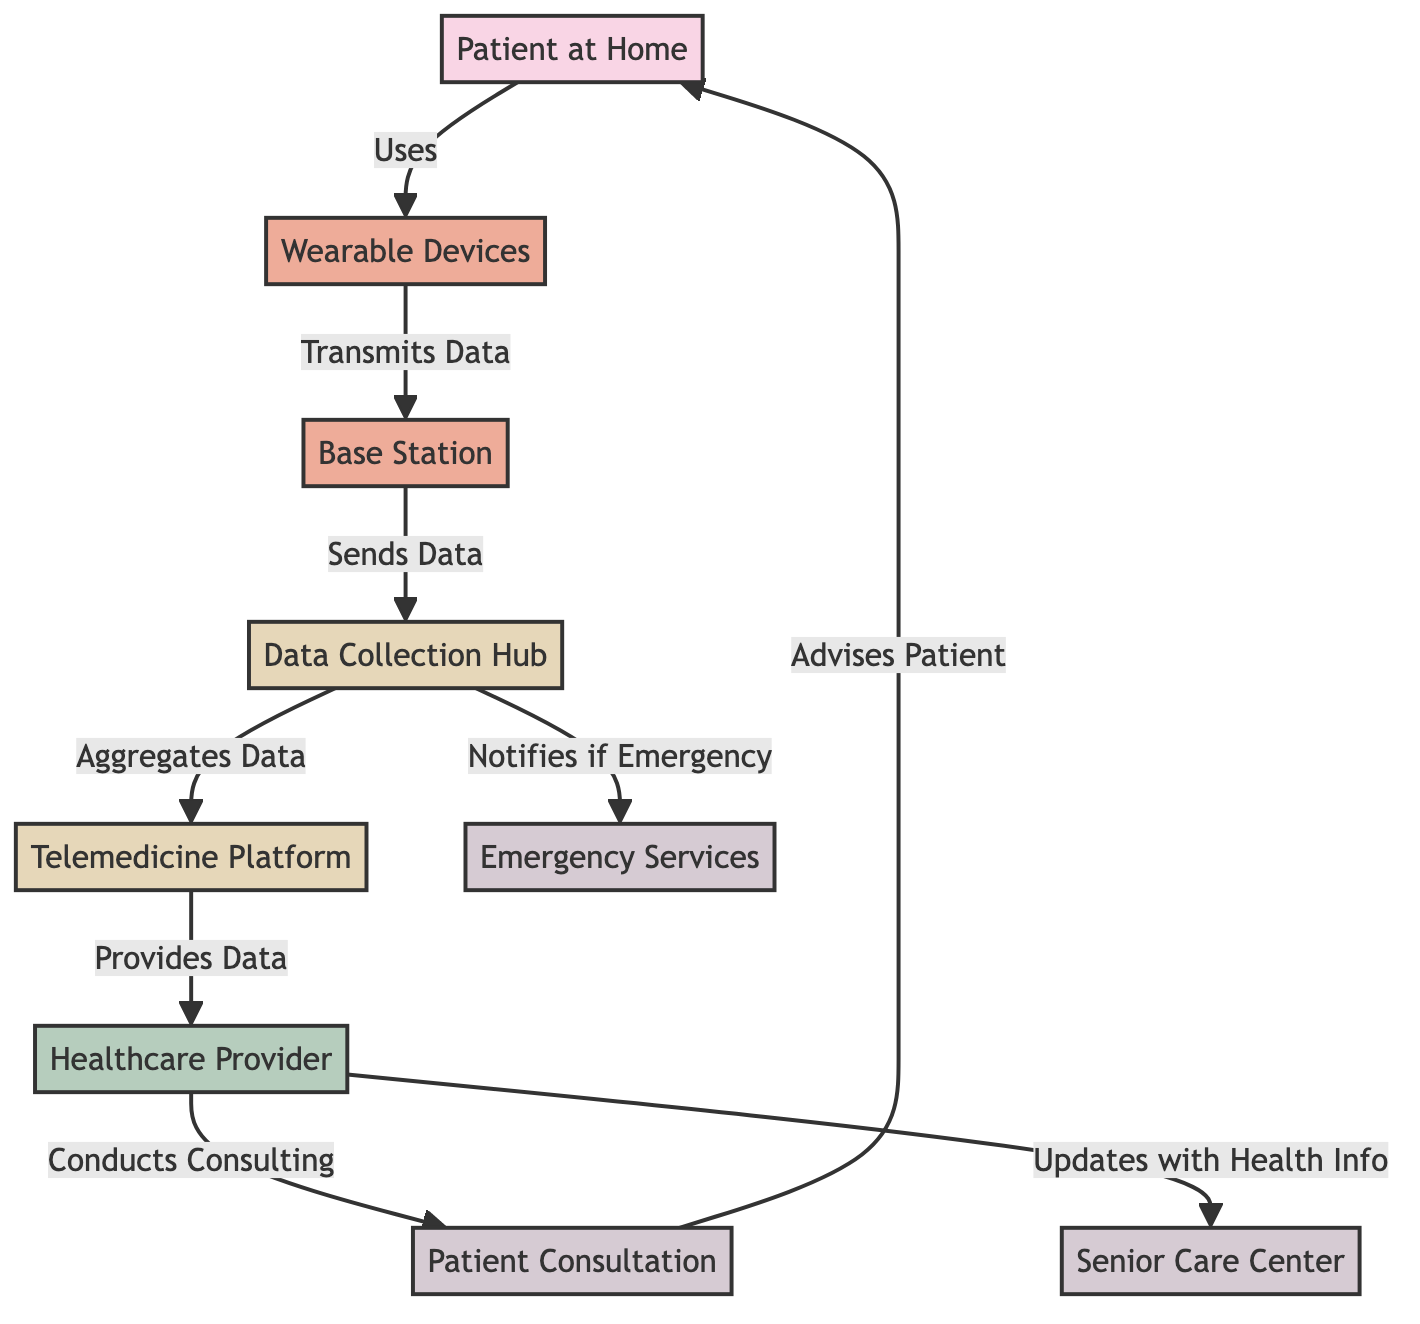What's the first step in the telemedicine process? The diagram indicates that the first step involves the "Patient at Home" using "Wearable Devices." This establishes the starting point of data collection in the telemedicine process.
Answer: Patient at Home How many wearable devices are illustrated in the diagram? The diagram includes one instance labeled "Wearable Devices," indicating there's a singular representation of this component.
Answer: One What does the "Base Station" do in this process? The "Base Station" transmits data from the "Wearable Devices" to the "Data Collection Hub," forming a crucial link in the data communication flow.
Answer: Transmits Data What is the outcome of the data collected from patients? The collected data is aggregated by the "Data Collection Hub," which indicates that this step organizes and prepares the information for the next stage of processing.
Answer: Aggregates Data What happens when an emergency is detected? If an emergency situation arises, the "Data Collection Hub" notifies "Emergency Services," showing the critical alert system in patient monitoring.
Answer: Notifies if Emergency How many services are listed in the diagram? The diagram shows four services: "Senior Care Center," "Patient Consultation," and "Emergency Services." Therefore, counting these nodes reveals this number.
Answer: Four What action does the healthcare provider take after conducting a consultation? After the consultation, the healthcare provider advises the patient, which illustrates the interactive and supportive role of the provider in patient care.
Answer: Advises Patient Which node is linked to the "Senior Care Center"? The "Healthcare Provider" updates health information to the "Senior Care Center," demonstrating the connection between these two entities in the telemedicine process.
Answer: Healthcare Provider What type of devices are involved in the telemedicine process? The diagram indicates "Wearable Devices" as the type of devices involved, which collect data crucial for remote patient monitoring.
Answer: Wearable Devices 